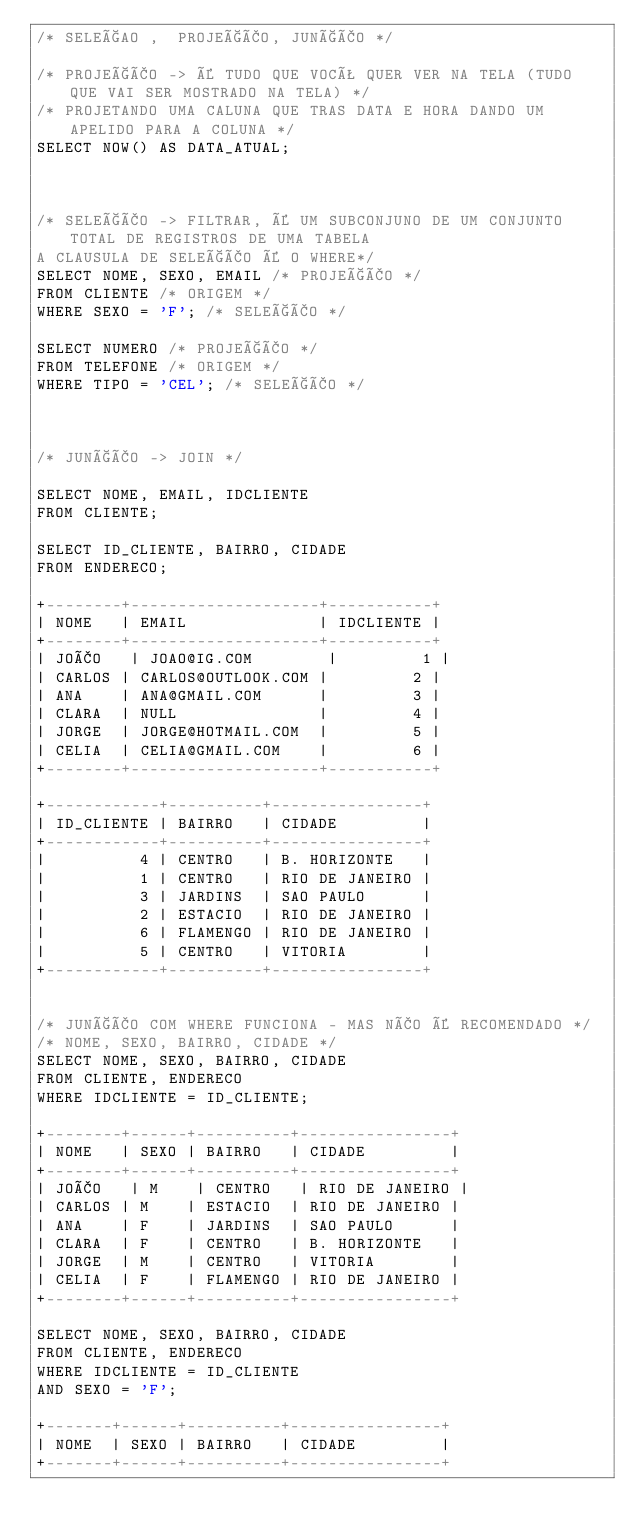<code> <loc_0><loc_0><loc_500><loc_500><_SQL_>/* SELEÇAO ,  PROJEÇÃO, JUNÇÃO */

/* PROJEÇÃO -> É TUDO QUE VOCÊ QUER VER NA TELA (TUDO QUE VAI SER MOSTRADO NA TELA) */
/* PROJETANDO UMA CALUNA QUE TRAS DATA E HORA DANDO UM APELIDO PARA A COLUNA */
SELECT NOW() AS DATA_ATUAL;



/* SELEÇÃO -> FILTRAR, É UM SUBCONJUNO DE UM CONJUNTO TOTAL DE REGISTROS DE UMA TABELA 
A CLAUSULA DE SELEÇÃO É O WHERE*/
SELECT NOME, SEXO, EMAIL /* PROJEÇÃO */
FROM CLIENTE /* ORIGEM */
WHERE SEXO = 'F'; /* SELEÇÃO */

SELECT NUMERO /* PROJEÇÃO */
FROM TELEFONE /* ORIGEM */
WHERE TIPO = 'CEL'; /* SELEÇÃO */



/* JUNÇÃO -> JOIN */

SELECT NOME, EMAIL, IDCLIENTE
FROM CLIENTE; 

SELECT ID_CLIENTE, BAIRRO, CIDADE
FROM ENDERECO;

+--------+--------------------+-----------+
| NOME   | EMAIL              | IDCLIENTE |
+--------+--------------------+-----------+
| JOÃO   | JOAO@IG.COM        |         1 |
| CARLOS | CARLOS@OUTLOOK.COM |         2 |
| ANA    | ANA@GMAIL.COM      |         3 |
| CLARA  | NULL               |         4 |
| JORGE  | JORGE@HOTMAIL.COM  |         5 |
| CELIA  | CELIA@GMAIL.COM    |         6 |
+--------+--------------------+-----------+

+------------+----------+----------------+
| ID_CLIENTE | BAIRRO   | CIDADE         |
+------------+----------+----------------+
|          4 | CENTRO   | B. HORIZONTE   |
|          1 | CENTRO   | RIO DE JANEIRO |
|          3 | JARDINS  | SAO PAULO      |
|          2 | ESTACIO  | RIO DE JANEIRO |
|          6 | FLAMENGO | RIO DE JANEIRO |
|          5 | CENTRO   | VITORIA        |
+------------+----------+----------------+


/* JUNÇÃO COM WHERE FUNCIONA - MAS NÃO É RECOMENDADO */
/* NOME, SEXO, BAIRRO, CIDADE */
SELECT NOME, SEXO, BAIRRO, CIDADE 
FROM CLIENTE, ENDERECO
WHERE IDCLIENTE = ID_CLIENTE;

+--------+------+----------+----------------+
| NOME   | SEXO | BAIRRO   | CIDADE         |
+--------+------+----------+----------------+
| JOÃO   | M    | CENTRO   | RIO DE JANEIRO |
| CARLOS | M    | ESTACIO  | RIO DE JANEIRO |
| ANA    | F    | JARDINS  | SAO PAULO      |
| CLARA  | F    | CENTRO   | B. HORIZONTE   |
| JORGE  | M    | CENTRO   | VITORIA        |
| CELIA  | F    | FLAMENGO | RIO DE JANEIRO |
+--------+------+----------+----------------+

SELECT NOME, SEXO, BAIRRO, CIDADE 
FROM CLIENTE, ENDERECO
WHERE IDCLIENTE = ID_CLIENTE
AND SEXO = 'F';

+-------+------+----------+----------------+
| NOME  | SEXO | BAIRRO   | CIDADE         |
+-------+------+----------+----------------+</code> 